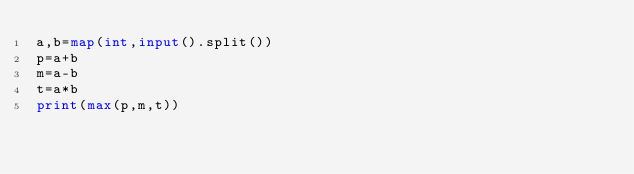Convert code to text. <code><loc_0><loc_0><loc_500><loc_500><_Python_>a,b=map(int,input().split())
p=a+b
m=a-b
t=a*b
print(max(p,m,t))
</code> 